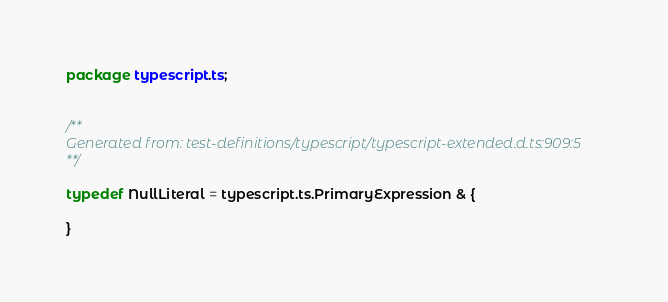<code> <loc_0><loc_0><loc_500><loc_500><_Haxe_>package typescript.ts;


/**
Generated from: test-definitions/typescript/typescript-extended.d.ts:909:5
**/

typedef NullLiteral = typescript.ts.PrimaryExpression & {

}

</code> 